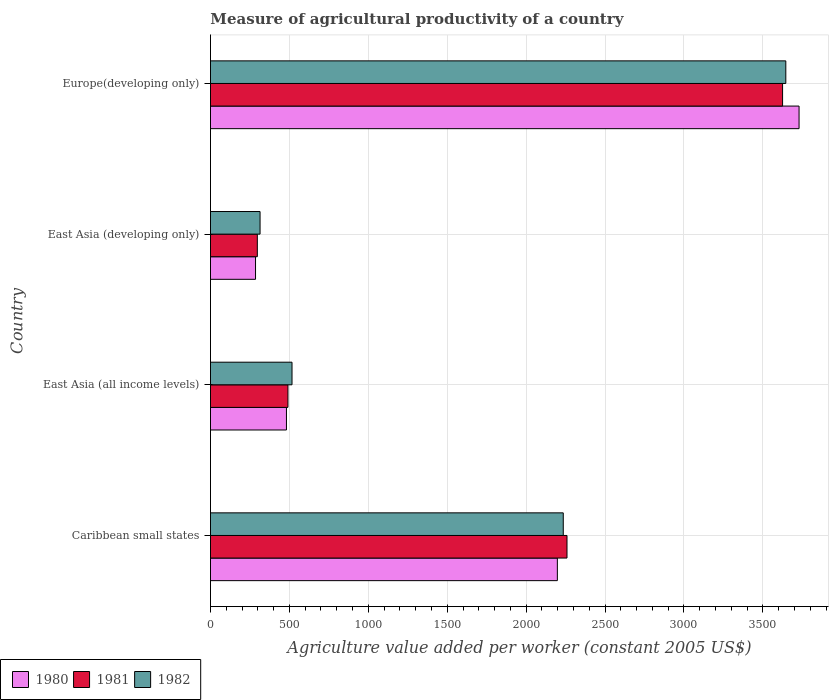How many groups of bars are there?
Provide a succinct answer. 4. How many bars are there on the 2nd tick from the top?
Keep it short and to the point. 3. How many bars are there on the 1st tick from the bottom?
Provide a short and direct response. 3. What is the label of the 3rd group of bars from the top?
Your response must be concise. East Asia (all income levels). In how many cases, is the number of bars for a given country not equal to the number of legend labels?
Keep it short and to the point. 0. What is the measure of agricultural productivity in 1981 in East Asia (all income levels)?
Provide a succinct answer. 490.9. Across all countries, what is the maximum measure of agricultural productivity in 1982?
Provide a short and direct response. 3645.29. Across all countries, what is the minimum measure of agricultural productivity in 1980?
Provide a succinct answer. 285.53. In which country was the measure of agricultural productivity in 1981 maximum?
Your answer should be compact. Europe(developing only). In which country was the measure of agricultural productivity in 1982 minimum?
Your response must be concise. East Asia (developing only). What is the total measure of agricultural productivity in 1982 in the graph?
Provide a short and direct response. 6711.41. What is the difference between the measure of agricultural productivity in 1982 in Caribbean small states and that in Europe(developing only)?
Your answer should be very brief. -1410.06. What is the difference between the measure of agricultural productivity in 1982 in East Asia (all income levels) and the measure of agricultural productivity in 1980 in East Asia (developing only)?
Provide a short and direct response. 231.17. What is the average measure of agricultural productivity in 1982 per country?
Your response must be concise. 1677.85. What is the difference between the measure of agricultural productivity in 1981 and measure of agricultural productivity in 1980 in Europe(developing only)?
Offer a terse response. -104.48. What is the ratio of the measure of agricultural productivity in 1982 in East Asia (all income levels) to that in East Asia (developing only)?
Give a very brief answer. 1.64. Is the difference between the measure of agricultural productivity in 1981 in East Asia (all income levels) and Europe(developing only) greater than the difference between the measure of agricultural productivity in 1980 in East Asia (all income levels) and Europe(developing only)?
Give a very brief answer. Yes. What is the difference between the highest and the second highest measure of agricultural productivity in 1982?
Offer a terse response. 1410.06. What is the difference between the highest and the lowest measure of agricultural productivity in 1981?
Your response must be concise. 3327.87. In how many countries, is the measure of agricultural productivity in 1982 greater than the average measure of agricultural productivity in 1982 taken over all countries?
Keep it short and to the point. 2. Is the sum of the measure of agricultural productivity in 1981 in East Asia (all income levels) and Europe(developing only) greater than the maximum measure of agricultural productivity in 1982 across all countries?
Your answer should be very brief. Yes. What does the 2nd bar from the top in Caribbean small states represents?
Give a very brief answer. 1981. What does the 2nd bar from the bottom in Caribbean small states represents?
Keep it short and to the point. 1981. Are the values on the major ticks of X-axis written in scientific E-notation?
Offer a very short reply. No. Does the graph contain any zero values?
Offer a terse response. No. Does the graph contain grids?
Ensure brevity in your answer.  Yes. How many legend labels are there?
Make the answer very short. 3. How are the legend labels stacked?
Make the answer very short. Horizontal. What is the title of the graph?
Keep it short and to the point. Measure of agricultural productivity of a country. What is the label or title of the X-axis?
Keep it short and to the point. Agriculture value added per worker (constant 2005 US$). What is the label or title of the Y-axis?
Ensure brevity in your answer.  Country. What is the Agriculture value added per worker (constant 2005 US$) in 1980 in Caribbean small states?
Provide a short and direct response. 2197.88. What is the Agriculture value added per worker (constant 2005 US$) in 1981 in Caribbean small states?
Give a very brief answer. 2258.9. What is the Agriculture value added per worker (constant 2005 US$) in 1982 in Caribbean small states?
Ensure brevity in your answer.  2235.23. What is the Agriculture value added per worker (constant 2005 US$) in 1980 in East Asia (all income levels)?
Provide a succinct answer. 481.44. What is the Agriculture value added per worker (constant 2005 US$) in 1981 in East Asia (all income levels)?
Give a very brief answer. 490.9. What is the Agriculture value added per worker (constant 2005 US$) in 1982 in East Asia (all income levels)?
Give a very brief answer. 516.7. What is the Agriculture value added per worker (constant 2005 US$) of 1980 in East Asia (developing only)?
Make the answer very short. 285.53. What is the Agriculture value added per worker (constant 2005 US$) in 1981 in East Asia (developing only)?
Provide a succinct answer. 296.92. What is the Agriculture value added per worker (constant 2005 US$) of 1982 in East Asia (developing only)?
Ensure brevity in your answer.  314.18. What is the Agriculture value added per worker (constant 2005 US$) in 1980 in Europe(developing only)?
Your answer should be compact. 3729.27. What is the Agriculture value added per worker (constant 2005 US$) in 1981 in Europe(developing only)?
Offer a terse response. 3624.79. What is the Agriculture value added per worker (constant 2005 US$) of 1982 in Europe(developing only)?
Your answer should be very brief. 3645.29. Across all countries, what is the maximum Agriculture value added per worker (constant 2005 US$) of 1980?
Provide a short and direct response. 3729.27. Across all countries, what is the maximum Agriculture value added per worker (constant 2005 US$) in 1981?
Offer a terse response. 3624.79. Across all countries, what is the maximum Agriculture value added per worker (constant 2005 US$) in 1982?
Ensure brevity in your answer.  3645.29. Across all countries, what is the minimum Agriculture value added per worker (constant 2005 US$) in 1980?
Make the answer very short. 285.53. Across all countries, what is the minimum Agriculture value added per worker (constant 2005 US$) of 1981?
Make the answer very short. 296.92. Across all countries, what is the minimum Agriculture value added per worker (constant 2005 US$) of 1982?
Make the answer very short. 314.18. What is the total Agriculture value added per worker (constant 2005 US$) in 1980 in the graph?
Offer a very short reply. 6694.12. What is the total Agriculture value added per worker (constant 2005 US$) in 1981 in the graph?
Keep it short and to the point. 6671.51. What is the total Agriculture value added per worker (constant 2005 US$) of 1982 in the graph?
Keep it short and to the point. 6711.41. What is the difference between the Agriculture value added per worker (constant 2005 US$) in 1980 in Caribbean small states and that in East Asia (all income levels)?
Your response must be concise. 1716.44. What is the difference between the Agriculture value added per worker (constant 2005 US$) in 1981 in Caribbean small states and that in East Asia (all income levels)?
Offer a very short reply. 1768. What is the difference between the Agriculture value added per worker (constant 2005 US$) in 1982 in Caribbean small states and that in East Asia (all income levels)?
Keep it short and to the point. 1718.53. What is the difference between the Agriculture value added per worker (constant 2005 US$) of 1980 in Caribbean small states and that in East Asia (developing only)?
Your answer should be compact. 1912.35. What is the difference between the Agriculture value added per worker (constant 2005 US$) in 1981 in Caribbean small states and that in East Asia (developing only)?
Give a very brief answer. 1961.99. What is the difference between the Agriculture value added per worker (constant 2005 US$) of 1982 in Caribbean small states and that in East Asia (developing only)?
Provide a succinct answer. 1921.05. What is the difference between the Agriculture value added per worker (constant 2005 US$) of 1980 in Caribbean small states and that in Europe(developing only)?
Your response must be concise. -1531.39. What is the difference between the Agriculture value added per worker (constant 2005 US$) of 1981 in Caribbean small states and that in Europe(developing only)?
Provide a succinct answer. -1365.89. What is the difference between the Agriculture value added per worker (constant 2005 US$) in 1982 in Caribbean small states and that in Europe(developing only)?
Offer a terse response. -1410.06. What is the difference between the Agriculture value added per worker (constant 2005 US$) of 1980 in East Asia (all income levels) and that in East Asia (developing only)?
Give a very brief answer. 195.91. What is the difference between the Agriculture value added per worker (constant 2005 US$) of 1981 in East Asia (all income levels) and that in East Asia (developing only)?
Your answer should be compact. 193.99. What is the difference between the Agriculture value added per worker (constant 2005 US$) of 1982 in East Asia (all income levels) and that in East Asia (developing only)?
Give a very brief answer. 202.52. What is the difference between the Agriculture value added per worker (constant 2005 US$) of 1980 in East Asia (all income levels) and that in Europe(developing only)?
Offer a terse response. -3247.83. What is the difference between the Agriculture value added per worker (constant 2005 US$) of 1981 in East Asia (all income levels) and that in Europe(developing only)?
Provide a short and direct response. -3133.89. What is the difference between the Agriculture value added per worker (constant 2005 US$) in 1982 in East Asia (all income levels) and that in Europe(developing only)?
Your answer should be compact. -3128.59. What is the difference between the Agriculture value added per worker (constant 2005 US$) in 1980 in East Asia (developing only) and that in Europe(developing only)?
Give a very brief answer. -3443.74. What is the difference between the Agriculture value added per worker (constant 2005 US$) of 1981 in East Asia (developing only) and that in Europe(developing only)?
Provide a succinct answer. -3327.87. What is the difference between the Agriculture value added per worker (constant 2005 US$) in 1982 in East Asia (developing only) and that in Europe(developing only)?
Provide a short and direct response. -3331.11. What is the difference between the Agriculture value added per worker (constant 2005 US$) in 1980 in Caribbean small states and the Agriculture value added per worker (constant 2005 US$) in 1981 in East Asia (all income levels)?
Offer a terse response. 1706.98. What is the difference between the Agriculture value added per worker (constant 2005 US$) in 1980 in Caribbean small states and the Agriculture value added per worker (constant 2005 US$) in 1982 in East Asia (all income levels)?
Make the answer very short. 1681.18. What is the difference between the Agriculture value added per worker (constant 2005 US$) in 1981 in Caribbean small states and the Agriculture value added per worker (constant 2005 US$) in 1982 in East Asia (all income levels)?
Your answer should be very brief. 1742.2. What is the difference between the Agriculture value added per worker (constant 2005 US$) of 1980 in Caribbean small states and the Agriculture value added per worker (constant 2005 US$) of 1981 in East Asia (developing only)?
Your answer should be compact. 1900.96. What is the difference between the Agriculture value added per worker (constant 2005 US$) of 1980 in Caribbean small states and the Agriculture value added per worker (constant 2005 US$) of 1982 in East Asia (developing only)?
Your response must be concise. 1883.69. What is the difference between the Agriculture value added per worker (constant 2005 US$) in 1981 in Caribbean small states and the Agriculture value added per worker (constant 2005 US$) in 1982 in East Asia (developing only)?
Offer a very short reply. 1944.72. What is the difference between the Agriculture value added per worker (constant 2005 US$) in 1980 in Caribbean small states and the Agriculture value added per worker (constant 2005 US$) in 1981 in Europe(developing only)?
Ensure brevity in your answer.  -1426.91. What is the difference between the Agriculture value added per worker (constant 2005 US$) in 1980 in Caribbean small states and the Agriculture value added per worker (constant 2005 US$) in 1982 in Europe(developing only)?
Provide a succinct answer. -1447.41. What is the difference between the Agriculture value added per worker (constant 2005 US$) of 1981 in Caribbean small states and the Agriculture value added per worker (constant 2005 US$) of 1982 in Europe(developing only)?
Ensure brevity in your answer.  -1386.39. What is the difference between the Agriculture value added per worker (constant 2005 US$) in 1980 in East Asia (all income levels) and the Agriculture value added per worker (constant 2005 US$) in 1981 in East Asia (developing only)?
Ensure brevity in your answer.  184.53. What is the difference between the Agriculture value added per worker (constant 2005 US$) of 1980 in East Asia (all income levels) and the Agriculture value added per worker (constant 2005 US$) of 1982 in East Asia (developing only)?
Make the answer very short. 167.26. What is the difference between the Agriculture value added per worker (constant 2005 US$) in 1981 in East Asia (all income levels) and the Agriculture value added per worker (constant 2005 US$) in 1982 in East Asia (developing only)?
Offer a terse response. 176.72. What is the difference between the Agriculture value added per worker (constant 2005 US$) of 1980 in East Asia (all income levels) and the Agriculture value added per worker (constant 2005 US$) of 1981 in Europe(developing only)?
Offer a terse response. -3143.35. What is the difference between the Agriculture value added per worker (constant 2005 US$) of 1980 in East Asia (all income levels) and the Agriculture value added per worker (constant 2005 US$) of 1982 in Europe(developing only)?
Your response must be concise. -3163.85. What is the difference between the Agriculture value added per worker (constant 2005 US$) in 1981 in East Asia (all income levels) and the Agriculture value added per worker (constant 2005 US$) in 1982 in Europe(developing only)?
Make the answer very short. -3154.39. What is the difference between the Agriculture value added per worker (constant 2005 US$) in 1980 in East Asia (developing only) and the Agriculture value added per worker (constant 2005 US$) in 1981 in Europe(developing only)?
Your response must be concise. -3339.26. What is the difference between the Agriculture value added per worker (constant 2005 US$) of 1980 in East Asia (developing only) and the Agriculture value added per worker (constant 2005 US$) of 1982 in Europe(developing only)?
Provide a short and direct response. -3359.76. What is the difference between the Agriculture value added per worker (constant 2005 US$) in 1981 in East Asia (developing only) and the Agriculture value added per worker (constant 2005 US$) in 1982 in Europe(developing only)?
Provide a short and direct response. -3348.38. What is the average Agriculture value added per worker (constant 2005 US$) of 1980 per country?
Keep it short and to the point. 1673.53. What is the average Agriculture value added per worker (constant 2005 US$) of 1981 per country?
Keep it short and to the point. 1667.88. What is the average Agriculture value added per worker (constant 2005 US$) of 1982 per country?
Provide a short and direct response. 1677.85. What is the difference between the Agriculture value added per worker (constant 2005 US$) in 1980 and Agriculture value added per worker (constant 2005 US$) in 1981 in Caribbean small states?
Offer a very short reply. -61.02. What is the difference between the Agriculture value added per worker (constant 2005 US$) of 1980 and Agriculture value added per worker (constant 2005 US$) of 1982 in Caribbean small states?
Your answer should be very brief. -37.36. What is the difference between the Agriculture value added per worker (constant 2005 US$) of 1981 and Agriculture value added per worker (constant 2005 US$) of 1982 in Caribbean small states?
Provide a succinct answer. 23.67. What is the difference between the Agriculture value added per worker (constant 2005 US$) of 1980 and Agriculture value added per worker (constant 2005 US$) of 1981 in East Asia (all income levels)?
Your response must be concise. -9.46. What is the difference between the Agriculture value added per worker (constant 2005 US$) in 1980 and Agriculture value added per worker (constant 2005 US$) in 1982 in East Asia (all income levels)?
Give a very brief answer. -35.26. What is the difference between the Agriculture value added per worker (constant 2005 US$) of 1981 and Agriculture value added per worker (constant 2005 US$) of 1982 in East Asia (all income levels)?
Give a very brief answer. -25.8. What is the difference between the Agriculture value added per worker (constant 2005 US$) in 1980 and Agriculture value added per worker (constant 2005 US$) in 1981 in East Asia (developing only)?
Provide a succinct answer. -11.39. What is the difference between the Agriculture value added per worker (constant 2005 US$) in 1980 and Agriculture value added per worker (constant 2005 US$) in 1982 in East Asia (developing only)?
Ensure brevity in your answer.  -28.66. What is the difference between the Agriculture value added per worker (constant 2005 US$) of 1981 and Agriculture value added per worker (constant 2005 US$) of 1982 in East Asia (developing only)?
Offer a very short reply. -17.27. What is the difference between the Agriculture value added per worker (constant 2005 US$) of 1980 and Agriculture value added per worker (constant 2005 US$) of 1981 in Europe(developing only)?
Provide a short and direct response. 104.48. What is the difference between the Agriculture value added per worker (constant 2005 US$) in 1980 and Agriculture value added per worker (constant 2005 US$) in 1982 in Europe(developing only)?
Your answer should be compact. 83.98. What is the difference between the Agriculture value added per worker (constant 2005 US$) in 1981 and Agriculture value added per worker (constant 2005 US$) in 1982 in Europe(developing only)?
Your response must be concise. -20.5. What is the ratio of the Agriculture value added per worker (constant 2005 US$) in 1980 in Caribbean small states to that in East Asia (all income levels)?
Make the answer very short. 4.57. What is the ratio of the Agriculture value added per worker (constant 2005 US$) of 1981 in Caribbean small states to that in East Asia (all income levels)?
Your answer should be very brief. 4.6. What is the ratio of the Agriculture value added per worker (constant 2005 US$) of 1982 in Caribbean small states to that in East Asia (all income levels)?
Make the answer very short. 4.33. What is the ratio of the Agriculture value added per worker (constant 2005 US$) in 1980 in Caribbean small states to that in East Asia (developing only)?
Ensure brevity in your answer.  7.7. What is the ratio of the Agriculture value added per worker (constant 2005 US$) of 1981 in Caribbean small states to that in East Asia (developing only)?
Make the answer very short. 7.61. What is the ratio of the Agriculture value added per worker (constant 2005 US$) in 1982 in Caribbean small states to that in East Asia (developing only)?
Your answer should be compact. 7.11. What is the ratio of the Agriculture value added per worker (constant 2005 US$) in 1980 in Caribbean small states to that in Europe(developing only)?
Give a very brief answer. 0.59. What is the ratio of the Agriculture value added per worker (constant 2005 US$) in 1981 in Caribbean small states to that in Europe(developing only)?
Make the answer very short. 0.62. What is the ratio of the Agriculture value added per worker (constant 2005 US$) in 1982 in Caribbean small states to that in Europe(developing only)?
Offer a very short reply. 0.61. What is the ratio of the Agriculture value added per worker (constant 2005 US$) in 1980 in East Asia (all income levels) to that in East Asia (developing only)?
Ensure brevity in your answer.  1.69. What is the ratio of the Agriculture value added per worker (constant 2005 US$) in 1981 in East Asia (all income levels) to that in East Asia (developing only)?
Give a very brief answer. 1.65. What is the ratio of the Agriculture value added per worker (constant 2005 US$) in 1982 in East Asia (all income levels) to that in East Asia (developing only)?
Make the answer very short. 1.64. What is the ratio of the Agriculture value added per worker (constant 2005 US$) of 1980 in East Asia (all income levels) to that in Europe(developing only)?
Offer a terse response. 0.13. What is the ratio of the Agriculture value added per worker (constant 2005 US$) in 1981 in East Asia (all income levels) to that in Europe(developing only)?
Make the answer very short. 0.14. What is the ratio of the Agriculture value added per worker (constant 2005 US$) in 1982 in East Asia (all income levels) to that in Europe(developing only)?
Your answer should be compact. 0.14. What is the ratio of the Agriculture value added per worker (constant 2005 US$) in 1980 in East Asia (developing only) to that in Europe(developing only)?
Make the answer very short. 0.08. What is the ratio of the Agriculture value added per worker (constant 2005 US$) in 1981 in East Asia (developing only) to that in Europe(developing only)?
Offer a very short reply. 0.08. What is the ratio of the Agriculture value added per worker (constant 2005 US$) in 1982 in East Asia (developing only) to that in Europe(developing only)?
Your response must be concise. 0.09. What is the difference between the highest and the second highest Agriculture value added per worker (constant 2005 US$) in 1980?
Your answer should be compact. 1531.39. What is the difference between the highest and the second highest Agriculture value added per worker (constant 2005 US$) in 1981?
Provide a short and direct response. 1365.89. What is the difference between the highest and the second highest Agriculture value added per worker (constant 2005 US$) in 1982?
Offer a very short reply. 1410.06. What is the difference between the highest and the lowest Agriculture value added per worker (constant 2005 US$) of 1980?
Your response must be concise. 3443.74. What is the difference between the highest and the lowest Agriculture value added per worker (constant 2005 US$) of 1981?
Offer a terse response. 3327.87. What is the difference between the highest and the lowest Agriculture value added per worker (constant 2005 US$) in 1982?
Offer a terse response. 3331.11. 